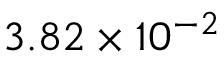Convert formula to latex. <formula><loc_0><loc_0><loc_500><loc_500>3 . 8 2 \times 1 0 ^ { - 2 }</formula> 